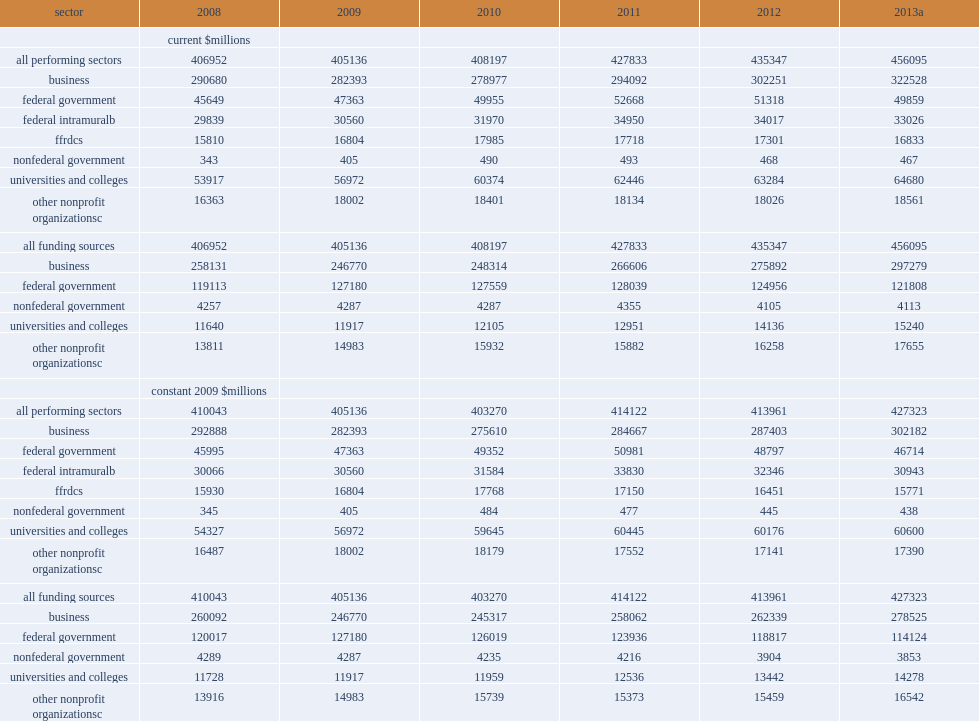How many million dollars did research and development performed in the united states total in 2013? 456095.0. How many million dollars did research and development performed in the united states total in 2012? 435347.0. How many million dollars did research and development performed in the united states total in 2011? 427833.0. How many million dollars did research and development performed in the united states total in 2008? 406952.0. 